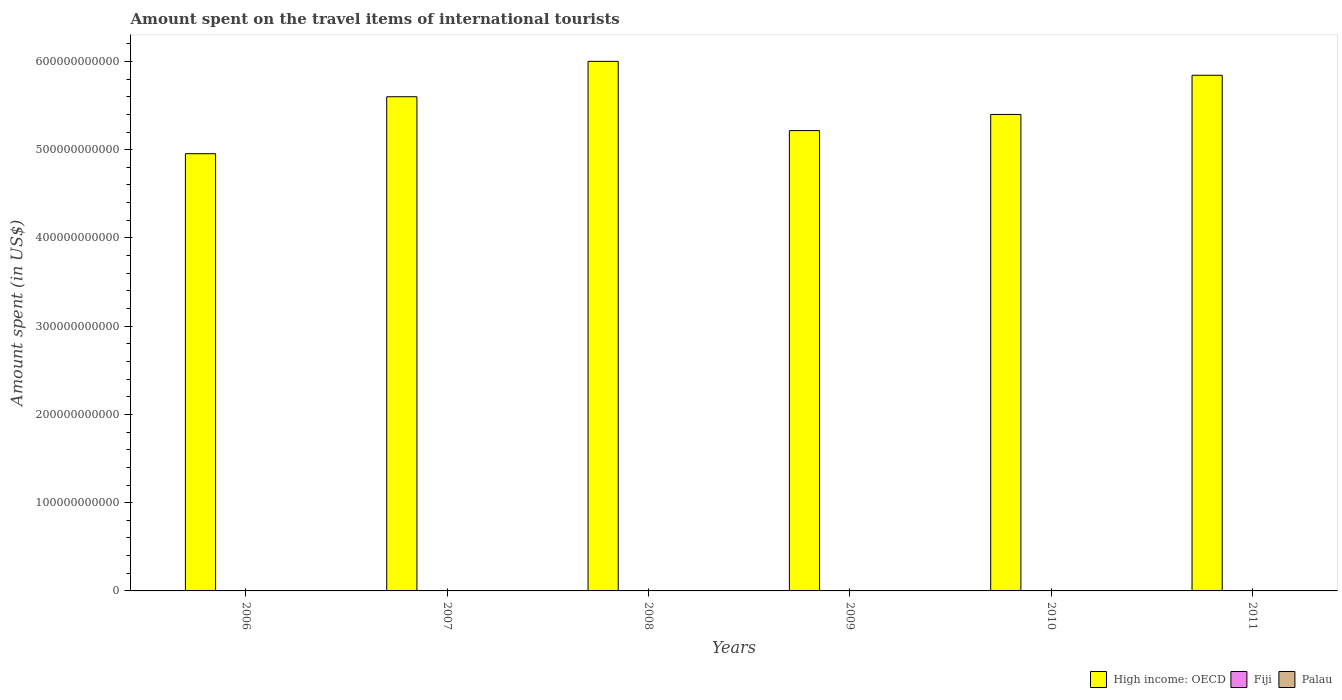How many different coloured bars are there?
Your answer should be very brief. 3. How many groups of bars are there?
Offer a terse response. 6. Are the number of bars on each tick of the X-axis equal?
Provide a short and direct response. Yes. How many bars are there on the 4th tick from the right?
Your answer should be compact. 3. What is the label of the 2nd group of bars from the left?
Give a very brief answer. 2007. What is the amount spent on the travel items of international tourists in Fiji in 2006?
Give a very brief answer. 1.01e+08. Across all years, what is the maximum amount spent on the travel items of international tourists in Palau?
Give a very brief answer. 8.40e+06. Across all years, what is the minimum amount spent on the travel items of international tourists in Fiji?
Give a very brief answer. 8.80e+07. In which year was the amount spent on the travel items of international tourists in High income: OECD minimum?
Offer a terse response. 2006. What is the total amount spent on the travel items of international tourists in Fiji in the graph?
Your answer should be very brief. 5.69e+08. What is the difference between the amount spent on the travel items of international tourists in Fiji in 2007 and that in 2011?
Your answer should be compact. -6.00e+06. What is the difference between the amount spent on the travel items of international tourists in Fiji in 2011 and the amount spent on the travel items of international tourists in Palau in 2008?
Ensure brevity in your answer.  8.99e+07. What is the average amount spent on the travel items of international tourists in Palau per year?
Provide a short and direct response. 7.55e+06. In the year 2011, what is the difference between the amount spent on the travel items of international tourists in Fiji and amount spent on the travel items of international tourists in High income: OECD?
Give a very brief answer. -5.84e+11. In how many years, is the amount spent on the travel items of international tourists in Palau greater than 40000000000 US$?
Make the answer very short. 0. What is the ratio of the amount spent on the travel items of international tourists in High income: OECD in 2008 to that in 2009?
Provide a succinct answer. 1.15. What is the difference between the highest and the lowest amount spent on the travel items of international tourists in Fiji?
Keep it short and to the point. 1.30e+07. What does the 1st bar from the left in 2011 represents?
Keep it short and to the point. High income: OECD. What does the 1st bar from the right in 2011 represents?
Your answer should be compact. Palau. Is it the case that in every year, the sum of the amount spent on the travel items of international tourists in Fiji and amount spent on the travel items of international tourists in Palau is greater than the amount spent on the travel items of international tourists in High income: OECD?
Provide a succinct answer. No. How many years are there in the graph?
Provide a short and direct response. 6. What is the difference between two consecutive major ticks on the Y-axis?
Offer a terse response. 1.00e+11. Does the graph contain any zero values?
Your response must be concise. No. Does the graph contain grids?
Give a very brief answer. No. Where does the legend appear in the graph?
Ensure brevity in your answer.  Bottom right. How are the legend labels stacked?
Your answer should be compact. Horizontal. What is the title of the graph?
Provide a short and direct response. Amount spent on the travel items of international tourists. Does "Senegal" appear as one of the legend labels in the graph?
Give a very brief answer. No. What is the label or title of the Y-axis?
Your answer should be compact. Amount spent (in US$). What is the Amount spent (in US$) in High income: OECD in 2006?
Your response must be concise. 4.95e+11. What is the Amount spent (in US$) of Fiji in 2006?
Your response must be concise. 1.01e+08. What is the Amount spent (in US$) of Palau in 2006?
Give a very brief answer. 8.10e+06. What is the Amount spent (in US$) in High income: OECD in 2007?
Your response must be concise. 5.60e+11. What is the Amount spent (in US$) of Fiji in 2007?
Provide a short and direct response. 9.20e+07. What is the Amount spent (in US$) in Palau in 2007?
Make the answer very short. 8.40e+06. What is the Amount spent (in US$) of High income: OECD in 2008?
Offer a terse response. 6.00e+11. What is the Amount spent (in US$) in Fiji in 2008?
Offer a very short reply. 9.60e+07. What is the Amount spent (in US$) of Palau in 2008?
Your response must be concise. 8.10e+06. What is the Amount spent (in US$) in High income: OECD in 2009?
Offer a terse response. 5.22e+11. What is the Amount spent (in US$) in Fiji in 2009?
Your answer should be compact. 9.40e+07. What is the Amount spent (in US$) of Palau in 2009?
Give a very brief answer. 6.40e+06. What is the Amount spent (in US$) in High income: OECD in 2010?
Offer a very short reply. 5.40e+11. What is the Amount spent (in US$) in Fiji in 2010?
Provide a succinct answer. 8.80e+07. What is the Amount spent (in US$) in High income: OECD in 2011?
Provide a succinct answer. 5.84e+11. What is the Amount spent (in US$) in Fiji in 2011?
Provide a short and direct response. 9.80e+07. What is the Amount spent (in US$) in Palau in 2011?
Your answer should be very brief. 8.30e+06. Across all years, what is the maximum Amount spent (in US$) of High income: OECD?
Your response must be concise. 6.00e+11. Across all years, what is the maximum Amount spent (in US$) of Fiji?
Offer a very short reply. 1.01e+08. Across all years, what is the maximum Amount spent (in US$) of Palau?
Your answer should be very brief. 8.40e+06. Across all years, what is the minimum Amount spent (in US$) of High income: OECD?
Offer a terse response. 4.95e+11. Across all years, what is the minimum Amount spent (in US$) of Fiji?
Ensure brevity in your answer.  8.80e+07. Across all years, what is the minimum Amount spent (in US$) of Palau?
Give a very brief answer. 6.00e+06. What is the total Amount spent (in US$) in High income: OECD in the graph?
Give a very brief answer. 3.30e+12. What is the total Amount spent (in US$) in Fiji in the graph?
Make the answer very short. 5.69e+08. What is the total Amount spent (in US$) of Palau in the graph?
Provide a short and direct response. 4.53e+07. What is the difference between the Amount spent (in US$) of High income: OECD in 2006 and that in 2007?
Your answer should be very brief. -6.45e+1. What is the difference between the Amount spent (in US$) of Fiji in 2006 and that in 2007?
Offer a terse response. 9.00e+06. What is the difference between the Amount spent (in US$) in Palau in 2006 and that in 2007?
Your answer should be very brief. -3.00e+05. What is the difference between the Amount spent (in US$) of High income: OECD in 2006 and that in 2008?
Make the answer very short. -1.05e+11. What is the difference between the Amount spent (in US$) of Palau in 2006 and that in 2008?
Provide a short and direct response. 0. What is the difference between the Amount spent (in US$) of High income: OECD in 2006 and that in 2009?
Ensure brevity in your answer.  -2.62e+1. What is the difference between the Amount spent (in US$) of Fiji in 2006 and that in 2009?
Your answer should be very brief. 7.00e+06. What is the difference between the Amount spent (in US$) in Palau in 2006 and that in 2009?
Provide a succinct answer. 1.70e+06. What is the difference between the Amount spent (in US$) of High income: OECD in 2006 and that in 2010?
Make the answer very short. -4.45e+1. What is the difference between the Amount spent (in US$) in Fiji in 2006 and that in 2010?
Your response must be concise. 1.30e+07. What is the difference between the Amount spent (in US$) in Palau in 2006 and that in 2010?
Offer a terse response. 2.10e+06. What is the difference between the Amount spent (in US$) in High income: OECD in 2006 and that in 2011?
Your response must be concise. -8.89e+1. What is the difference between the Amount spent (in US$) of Fiji in 2006 and that in 2011?
Your answer should be compact. 3.00e+06. What is the difference between the Amount spent (in US$) of Palau in 2006 and that in 2011?
Offer a very short reply. -2.00e+05. What is the difference between the Amount spent (in US$) in High income: OECD in 2007 and that in 2008?
Ensure brevity in your answer.  -4.01e+1. What is the difference between the Amount spent (in US$) of High income: OECD in 2007 and that in 2009?
Offer a terse response. 3.84e+1. What is the difference between the Amount spent (in US$) of Palau in 2007 and that in 2009?
Provide a short and direct response. 2.00e+06. What is the difference between the Amount spent (in US$) in High income: OECD in 2007 and that in 2010?
Ensure brevity in your answer.  2.01e+1. What is the difference between the Amount spent (in US$) of Palau in 2007 and that in 2010?
Your answer should be very brief. 2.40e+06. What is the difference between the Amount spent (in US$) in High income: OECD in 2007 and that in 2011?
Ensure brevity in your answer.  -2.44e+1. What is the difference between the Amount spent (in US$) of Fiji in 2007 and that in 2011?
Offer a very short reply. -6.00e+06. What is the difference between the Amount spent (in US$) in High income: OECD in 2008 and that in 2009?
Offer a very short reply. 7.85e+1. What is the difference between the Amount spent (in US$) in Fiji in 2008 and that in 2009?
Keep it short and to the point. 2.00e+06. What is the difference between the Amount spent (in US$) in Palau in 2008 and that in 2009?
Your answer should be very brief. 1.70e+06. What is the difference between the Amount spent (in US$) in High income: OECD in 2008 and that in 2010?
Keep it short and to the point. 6.02e+1. What is the difference between the Amount spent (in US$) in Fiji in 2008 and that in 2010?
Your answer should be compact. 8.00e+06. What is the difference between the Amount spent (in US$) in Palau in 2008 and that in 2010?
Keep it short and to the point. 2.10e+06. What is the difference between the Amount spent (in US$) in High income: OECD in 2008 and that in 2011?
Ensure brevity in your answer.  1.57e+1. What is the difference between the Amount spent (in US$) of Palau in 2008 and that in 2011?
Your answer should be very brief. -2.00e+05. What is the difference between the Amount spent (in US$) in High income: OECD in 2009 and that in 2010?
Give a very brief answer. -1.83e+1. What is the difference between the Amount spent (in US$) of High income: OECD in 2009 and that in 2011?
Give a very brief answer. -6.27e+1. What is the difference between the Amount spent (in US$) of Palau in 2009 and that in 2011?
Provide a short and direct response. -1.90e+06. What is the difference between the Amount spent (in US$) of High income: OECD in 2010 and that in 2011?
Give a very brief answer. -4.44e+1. What is the difference between the Amount spent (in US$) of Fiji in 2010 and that in 2011?
Keep it short and to the point. -1.00e+07. What is the difference between the Amount spent (in US$) of Palau in 2010 and that in 2011?
Keep it short and to the point. -2.30e+06. What is the difference between the Amount spent (in US$) in High income: OECD in 2006 and the Amount spent (in US$) in Fiji in 2007?
Your answer should be compact. 4.95e+11. What is the difference between the Amount spent (in US$) in High income: OECD in 2006 and the Amount spent (in US$) in Palau in 2007?
Ensure brevity in your answer.  4.95e+11. What is the difference between the Amount spent (in US$) of Fiji in 2006 and the Amount spent (in US$) of Palau in 2007?
Provide a short and direct response. 9.26e+07. What is the difference between the Amount spent (in US$) in High income: OECD in 2006 and the Amount spent (in US$) in Fiji in 2008?
Offer a very short reply. 4.95e+11. What is the difference between the Amount spent (in US$) of High income: OECD in 2006 and the Amount spent (in US$) of Palau in 2008?
Give a very brief answer. 4.95e+11. What is the difference between the Amount spent (in US$) in Fiji in 2006 and the Amount spent (in US$) in Palau in 2008?
Ensure brevity in your answer.  9.29e+07. What is the difference between the Amount spent (in US$) of High income: OECD in 2006 and the Amount spent (in US$) of Fiji in 2009?
Ensure brevity in your answer.  4.95e+11. What is the difference between the Amount spent (in US$) in High income: OECD in 2006 and the Amount spent (in US$) in Palau in 2009?
Your response must be concise. 4.95e+11. What is the difference between the Amount spent (in US$) of Fiji in 2006 and the Amount spent (in US$) of Palau in 2009?
Your response must be concise. 9.46e+07. What is the difference between the Amount spent (in US$) in High income: OECD in 2006 and the Amount spent (in US$) in Fiji in 2010?
Ensure brevity in your answer.  4.95e+11. What is the difference between the Amount spent (in US$) of High income: OECD in 2006 and the Amount spent (in US$) of Palau in 2010?
Give a very brief answer. 4.95e+11. What is the difference between the Amount spent (in US$) of Fiji in 2006 and the Amount spent (in US$) of Palau in 2010?
Provide a succinct answer. 9.50e+07. What is the difference between the Amount spent (in US$) in High income: OECD in 2006 and the Amount spent (in US$) in Fiji in 2011?
Ensure brevity in your answer.  4.95e+11. What is the difference between the Amount spent (in US$) in High income: OECD in 2006 and the Amount spent (in US$) in Palau in 2011?
Provide a short and direct response. 4.95e+11. What is the difference between the Amount spent (in US$) of Fiji in 2006 and the Amount spent (in US$) of Palau in 2011?
Keep it short and to the point. 9.27e+07. What is the difference between the Amount spent (in US$) in High income: OECD in 2007 and the Amount spent (in US$) in Fiji in 2008?
Offer a very short reply. 5.60e+11. What is the difference between the Amount spent (in US$) of High income: OECD in 2007 and the Amount spent (in US$) of Palau in 2008?
Your answer should be compact. 5.60e+11. What is the difference between the Amount spent (in US$) in Fiji in 2007 and the Amount spent (in US$) in Palau in 2008?
Ensure brevity in your answer.  8.39e+07. What is the difference between the Amount spent (in US$) in High income: OECD in 2007 and the Amount spent (in US$) in Fiji in 2009?
Your response must be concise. 5.60e+11. What is the difference between the Amount spent (in US$) in High income: OECD in 2007 and the Amount spent (in US$) in Palau in 2009?
Your response must be concise. 5.60e+11. What is the difference between the Amount spent (in US$) of Fiji in 2007 and the Amount spent (in US$) of Palau in 2009?
Ensure brevity in your answer.  8.56e+07. What is the difference between the Amount spent (in US$) in High income: OECD in 2007 and the Amount spent (in US$) in Fiji in 2010?
Offer a terse response. 5.60e+11. What is the difference between the Amount spent (in US$) of High income: OECD in 2007 and the Amount spent (in US$) of Palau in 2010?
Your answer should be very brief. 5.60e+11. What is the difference between the Amount spent (in US$) of Fiji in 2007 and the Amount spent (in US$) of Palau in 2010?
Make the answer very short. 8.60e+07. What is the difference between the Amount spent (in US$) in High income: OECD in 2007 and the Amount spent (in US$) in Fiji in 2011?
Your answer should be very brief. 5.60e+11. What is the difference between the Amount spent (in US$) of High income: OECD in 2007 and the Amount spent (in US$) of Palau in 2011?
Your response must be concise. 5.60e+11. What is the difference between the Amount spent (in US$) of Fiji in 2007 and the Amount spent (in US$) of Palau in 2011?
Your response must be concise. 8.37e+07. What is the difference between the Amount spent (in US$) in High income: OECD in 2008 and the Amount spent (in US$) in Fiji in 2009?
Offer a very short reply. 6.00e+11. What is the difference between the Amount spent (in US$) of High income: OECD in 2008 and the Amount spent (in US$) of Palau in 2009?
Offer a terse response. 6.00e+11. What is the difference between the Amount spent (in US$) in Fiji in 2008 and the Amount spent (in US$) in Palau in 2009?
Keep it short and to the point. 8.96e+07. What is the difference between the Amount spent (in US$) in High income: OECD in 2008 and the Amount spent (in US$) in Fiji in 2010?
Offer a very short reply. 6.00e+11. What is the difference between the Amount spent (in US$) of High income: OECD in 2008 and the Amount spent (in US$) of Palau in 2010?
Your response must be concise. 6.00e+11. What is the difference between the Amount spent (in US$) of Fiji in 2008 and the Amount spent (in US$) of Palau in 2010?
Give a very brief answer. 9.00e+07. What is the difference between the Amount spent (in US$) in High income: OECD in 2008 and the Amount spent (in US$) in Fiji in 2011?
Your answer should be compact. 6.00e+11. What is the difference between the Amount spent (in US$) in High income: OECD in 2008 and the Amount spent (in US$) in Palau in 2011?
Give a very brief answer. 6.00e+11. What is the difference between the Amount spent (in US$) in Fiji in 2008 and the Amount spent (in US$) in Palau in 2011?
Give a very brief answer. 8.77e+07. What is the difference between the Amount spent (in US$) of High income: OECD in 2009 and the Amount spent (in US$) of Fiji in 2010?
Provide a short and direct response. 5.22e+11. What is the difference between the Amount spent (in US$) in High income: OECD in 2009 and the Amount spent (in US$) in Palau in 2010?
Make the answer very short. 5.22e+11. What is the difference between the Amount spent (in US$) in Fiji in 2009 and the Amount spent (in US$) in Palau in 2010?
Offer a terse response. 8.80e+07. What is the difference between the Amount spent (in US$) in High income: OECD in 2009 and the Amount spent (in US$) in Fiji in 2011?
Your answer should be compact. 5.22e+11. What is the difference between the Amount spent (in US$) of High income: OECD in 2009 and the Amount spent (in US$) of Palau in 2011?
Give a very brief answer. 5.22e+11. What is the difference between the Amount spent (in US$) of Fiji in 2009 and the Amount spent (in US$) of Palau in 2011?
Ensure brevity in your answer.  8.57e+07. What is the difference between the Amount spent (in US$) of High income: OECD in 2010 and the Amount spent (in US$) of Fiji in 2011?
Ensure brevity in your answer.  5.40e+11. What is the difference between the Amount spent (in US$) of High income: OECD in 2010 and the Amount spent (in US$) of Palau in 2011?
Provide a short and direct response. 5.40e+11. What is the difference between the Amount spent (in US$) of Fiji in 2010 and the Amount spent (in US$) of Palau in 2011?
Offer a very short reply. 7.97e+07. What is the average Amount spent (in US$) of High income: OECD per year?
Your response must be concise. 5.50e+11. What is the average Amount spent (in US$) in Fiji per year?
Your response must be concise. 9.48e+07. What is the average Amount spent (in US$) of Palau per year?
Offer a very short reply. 7.55e+06. In the year 2006, what is the difference between the Amount spent (in US$) of High income: OECD and Amount spent (in US$) of Fiji?
Keep it short and to the point. 4.95e+11. In the year 2006, what is the difference between the Amount spent (in US$) in High income: OECD and Amount spent (in US$) in Palau?
Make the answer very short. 4.95e+11. In the year 2006, what is the difference between the Amount spent (in US$) in Fiji and Amount spent (in US$) in Palau?
Offer a terse response. 9.29e+07. In the year 2007, what is the difference between the Amount spent (in US$) of High income: OECD and Amount spent (in US$) of Fiji?
Ensure brevity in your answer.  5.60e+11. In the year 2007, what is the difference between the Amount spent (in US$) of High income: OECD and Amount spent (in US$) of Palau?
Offer a terse response. 5.60e+11. In the year 2007, what is the difference between the Amount spent (in US$) of Fiji and Amount spent (in US$) of Palau?
Offer a very short reply. 8.36e+07. In the year 2008, what is the difference between the Amount spent (in US$) of High income: OECD and Amount spent (in US$) of Fiji?
Ensure brevity in your answer.  6.00e+11. In the year 2008, what is the difference between the Amount spent (in US$) of High income: OECD and Amount spent (in US$) of Palau?
Your response must be concise. 6.00e+11. In the year 2008, what is the difference between the Amount spent (in US$) of Fiji and Amount spent (in US$) of Palau?
Provide a succinct answer. 8.79e+07. In the year 2009, what is the difference between the Amount spent (in US$) of High income: OECD and Amount spent (in US$) of Fiji?
Your answer should be compact. 5.22e+11. In the year 2009, what is the difference between the Amount spent (in US$) of High income: OECD and Amount spent (in US$) of Palau?
Provide a succinct answer. 5.22e+11. In the year 2009, what is the difference between the Amount spent (in US$) in Fiji and Amount spent (in US$) in Palau?
Offer a terse response. 8.76e+07. In the year 2010, what is the difference between the Amount spent (in US$) of High income: OECD and Amount spent (in US$) of Fiji?
Give a very brief answer. 5.40e+11. In the year 2010, what is the difference between the Amount spent (in US$) of High income: OECD and Amount spent (in US$) of Palau?
Offer a terse response. 5.40e+11. In the year 2010, what is the difference between the Amount spent (in US$) in Fiji and Amount spent (in US$) in Palau?
Ensure brevity in your answer.  8.20e+07. In the year 2011, what is the difference between the Amount spent (in US$) of High income: OECD and Amount spent (in US$) of Fiji?
Keep it short and to the point. 5.84e+11. In the year 2011, what is the difference between the Amount spent (in US$) of High income: OECD and Amount spent (in US$) of Palau?
Your response must be concise. 5.84e+11. In the year 2011, what is the difference between the Amount spent (in US$) in Fiji and Amount spent (in US$) in Palau?
Offer a terse response. 8.97e+07. What is the ratio of the Amount spent (in US$) in High income: OECD in 2006 to that in 2007?
Your answer should be compact. 0.88. What is the ratio of the Amount spent (in US$) in Fiji in 2006 to that in 2007?
Provide a succinct answer. 1.1. What is the ratio of the Amount spent (in US$) of Palau in 2006 to that in 2007?
Offer a very short reply. 0.96. What is the ratio of the Amount spent (in US$) of High income: OECD in 2006 to that in 2008?
Make the answer very short. 0.83. What is the ratio of the Amount spent (in US$) of Fiji in 2006 to that in 2008?
Keep it short and to the point. 1.05. What is the ratio of the Amount spent (in US$) in Palau in 2006 to that in 2008?
Keep it short and to the point. 1. What is the ratio of the Amount spent (in US$) in High income: OECD in 2006 to that in 2009?
Provide a short and direct response. 0.95. What is the ratio of the Amount spent (in US$) of Fiji in 2006 to that in 2009?
Provide a short and direct response. 1.07. What is the ratio of the Amount spent (in US$) of Palau in 2006 to that in 2009?
Provide a succinct answer. 1.27. What is the ratio of the Amount spent (in US$) of High income: OECD in 2006 to that in 2010?
Provide a succinct answer. 0.92. What is the ratio of the Amount spent (in US$) of Fiji in 2006 to that in 2010?
Give a very brief answer. 1.15. What is the ratio of the Amount spent (in US$) in Palau in 2006 to that in 2010?
Make the answer very short. 1.35. What is the ratio of the Amount spent (in US$) of High income: OECD in 2006 to that in 2011?
Your answer should be compact. 0.85. What is the ratio of the Amount spent (in US$) in Fiji in 2006 to that in 2011?
Your answer should be very brief. 1.03. What is the ratio of the Amount spent (in US$) of Palau in 2006 to that in 2011?
Provide a short and direct response. 0.98. What is the ratio of the Amount spent (in US$) of High income: OECD in 2007 to that in 2008?
Offer a terse response. 0.93. What is the ratio of the Amount spent (in US$) in Palau in 2007 to that in 2008?
Ensure brevity in your answer.  1.04. What is the ratio of the Amount spent (in US$) of High income: OECD in 2007 to that in 2009?
Ensure brevity in your answer.  1.07. What is the ratio of the Amount spent (in US$) of Fiji in 2007 to that in 2009?
Your answer should be very brief. 0.98. What is the ratio of the Amount spent (in US$) in Palau in 2007 to that in 2009?
Give a very brief answer. 1.31. What is the ratio of the Amount spent (in US$) in High income: OECD in 2007 to that in 2010?
Your answer should be very brief. 1.04. What is the ratio of the Amount spent (in US$) in Fiji in 2007 to that in 2010?
Make the answer very short. 1.05. What is the ratio of the Amount spent (in US$) in Fiji in 2007 to that in 2011?
Provide a succinct answer. 0.94. What is the ratio of the Amount spent (in US$) in High income: OECD in 2008 to that in 2009?
Provide a succinct answer. 1.15. What is the ratio of the Amount spent (in US$) of Fiji in 2008 to that in 2009?
Offer a very short reply. 1.02. What is the ratio of the Amount spent (in US$) of Palau in 2008 to that in 2009?
Give a very brief answer. 1.27. What is the ratio of the Amount spent (in US$) in High income: OECD in 2008 to that in 2010?
Your answer should be very brief. 1.11. What is the ratio of the Amount spent (in US$) of Palau in 2008 to that in 2010?
Offer a very short reply. 1.35. What is the ratio of the Amount spent (in US$) in High income: OECD in 2008 to that in 2011?
Offer a very short reply. 1.03. What is the ratio of the Amount spent (in US$) of Fiji in 2008 to that in 2011?
Make the answer very short. 0.98. What is the ratio of the Amount spent (in US$) of Palau in 2008 to that in 2011?
Ensure brevity in your answer.  0.98. What is the ratio of the Amount spent (in US$) of High income: OECD in 2009 to that in 2010?
Your answer should be very brief. 0.97. What is the ratio of the Amount spent (in US$) in Fiji in 2009 to that in 2010?
Offer a terse response. 1.07. What is the ratio of the Amount spent (in US$) in Palau in 2009 to that in 2010?
Offer a terse response. 1.07. What is the ratio of the Amount spent (in US$) of High income: OECD in 2009 to that in 2011?
Provide a succinct answer. 0.89. What is the ratio of the Amount spent (in US$) of Fiji in 2009 to that in 2011?
Offer a very short reply. 0.96. What is the ratio of the Amount spent (in US$) of Palau in 2009 to that in 2011?
Keep it short and to the point. 0.77. What is the ratio of the Amount spent (in US$) of High income: OECD in 2010 to that in 2011?
Provide a succinct answer. 0.92. What is the ratio of the Amount spent (in US$) in Fiji in 2010 to that in 2011?
Provide a succinct answer. 0.9. What is the ratio of the Amount spent (in US$) in Palau in 2010 to that in 2011?
Offer a terse response. 0.72. What is the difference between the highest and the second highest Amount spent (in US$) of High income: OECD?
Make the answer very short. 1.57e+1. What is the difference between the highest and the second highest Amount spent (in US$) in Fiji?
Ensure brevity in your answer.  3.00e+06. What is the difference between the highest and the lowest Amount spent (in US$) of High income: OECD?
Your answer should be very brief. 1.05e+11. What is the difference between the highest and the lowest Amount spent (in US$) in Fiji?
Offer a very short reply. 1.30e+07. What is the difference between the highest and the lowest Amount spent (in US$) of Palau?
Ensure brevity in your answer.  2.40e+06. 